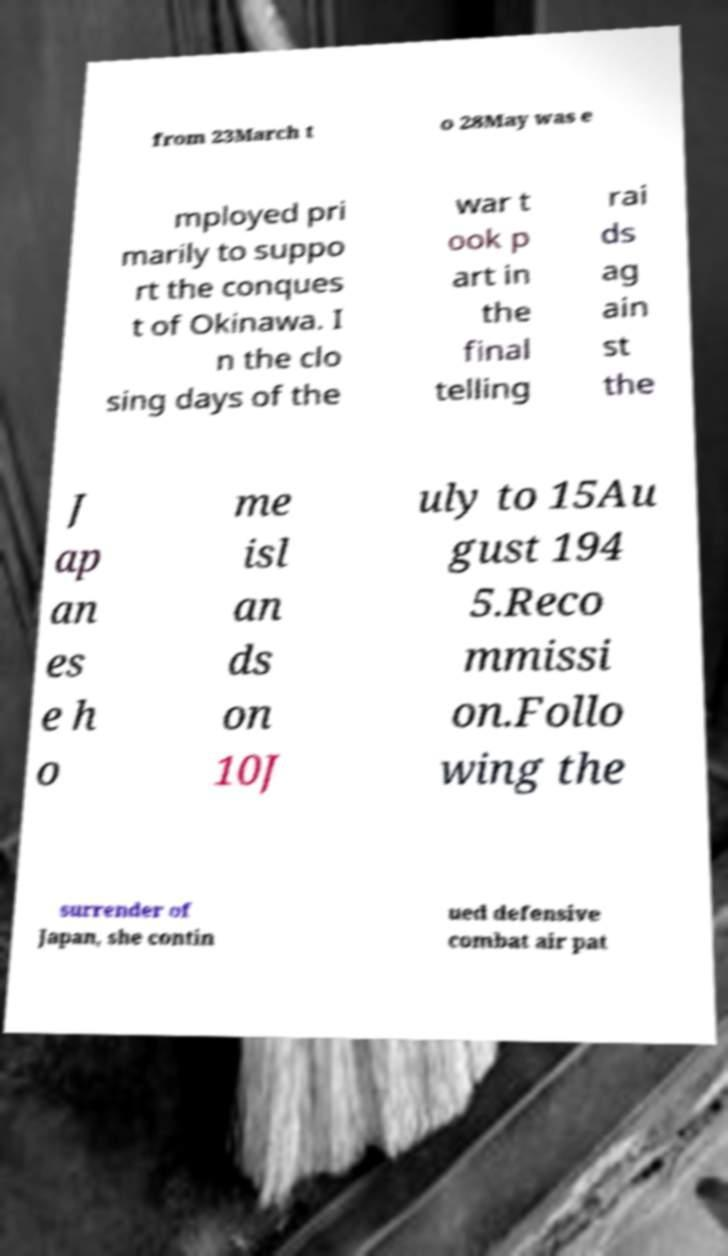Please read and relay the text visible in this image. What does it say? from 23March t o 28May was e mployed pri marily to suppo rt the conques t of Okinawa. I n the clo sing days of the war t ook p art in the final telling rai ds ag ain st the J ap an es e h o me isl an ds on 10J uly to 15Au gust 194 5.Reco mmissi on.Follo wing the surrender of Japan, she contin ued defensive combat air pat 